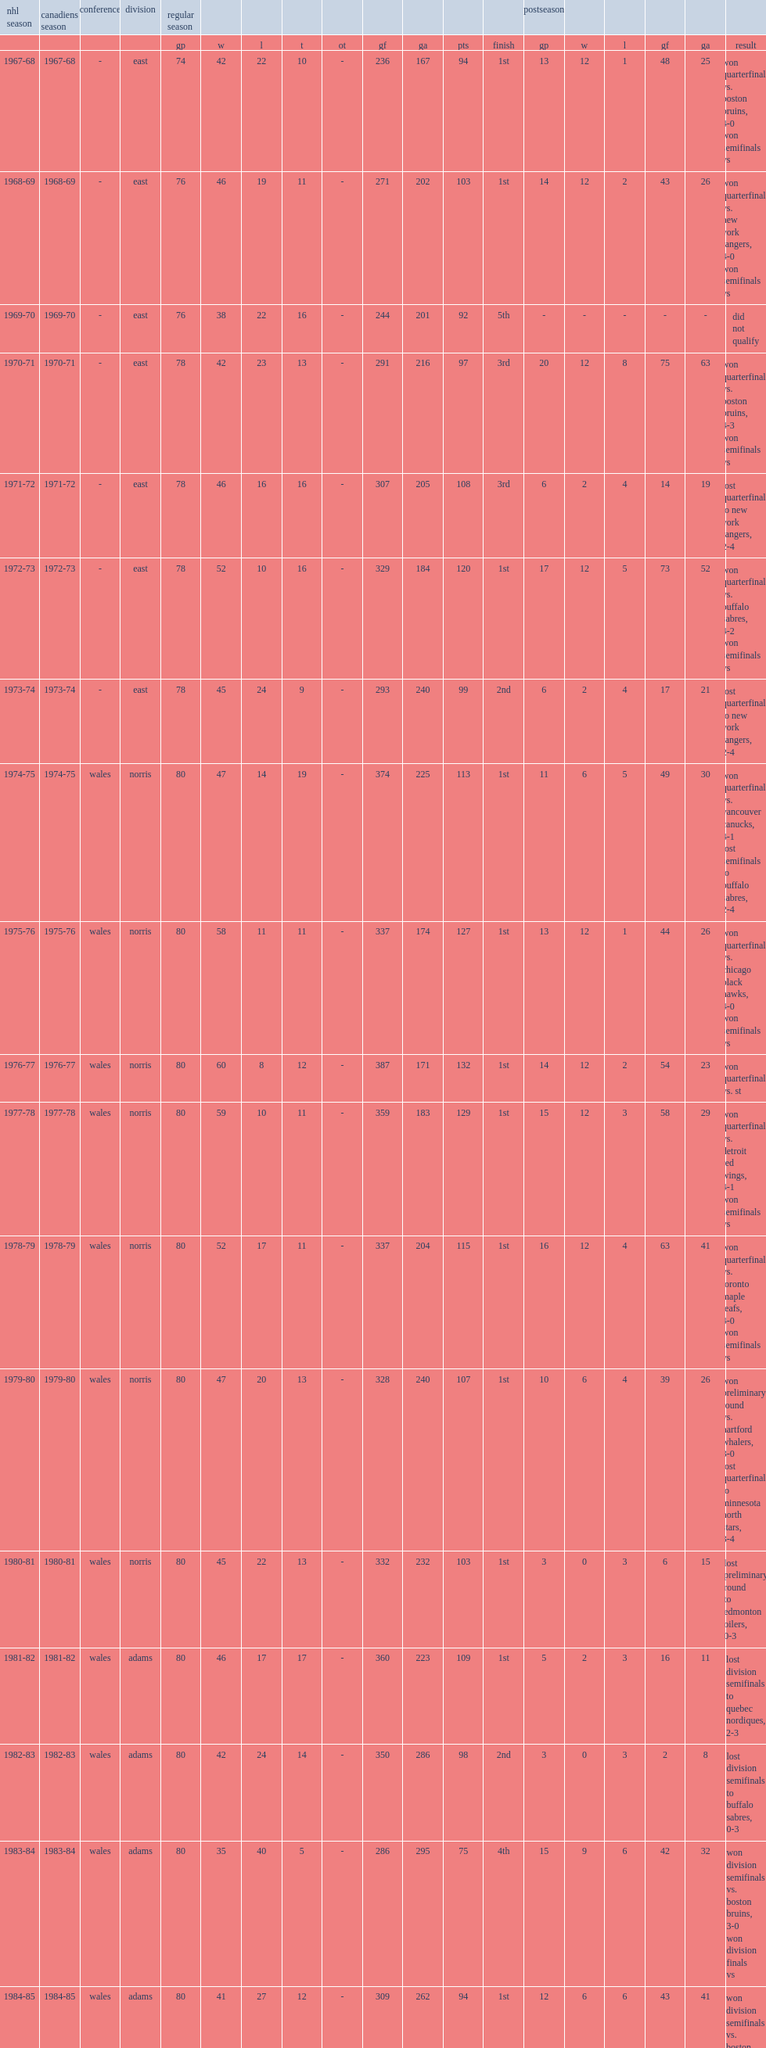During the 1972-73 montreal canadiens season, what is the final result for canadiens? 1st. 